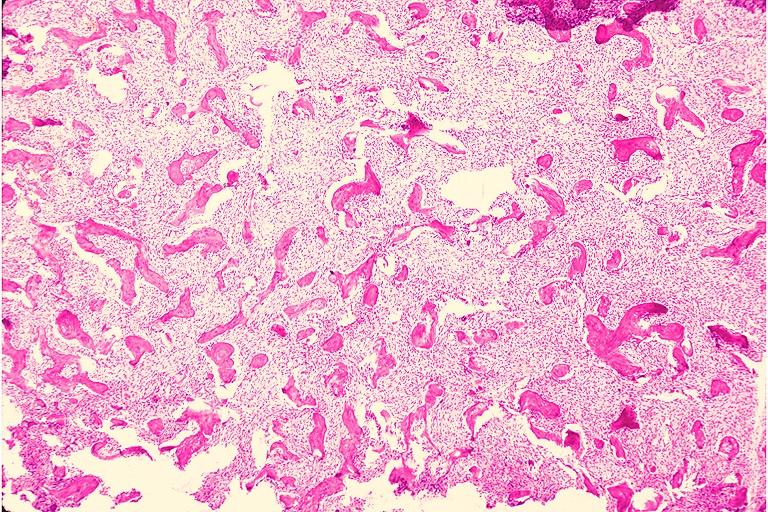what is present?
Answer the question using a single word or phrase. Oral 